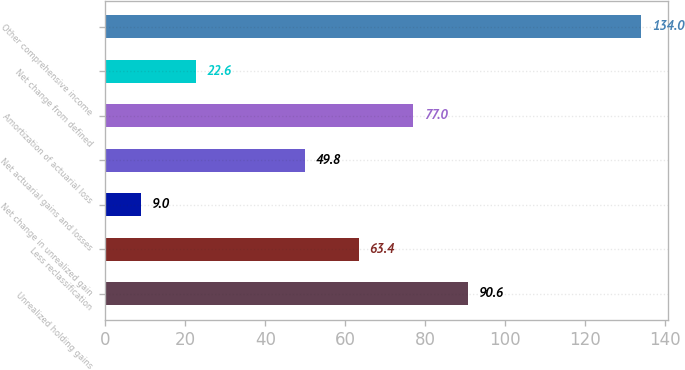Convert chart to OTSL. <chart><loc_0><loc_0><loc_500><loc_500><bar_chart><fcel>Unrealized holding gains<fcel>Less reclassification<fcel>Net change in unrealized gain<fcel>Net actuarial gains and losses<fcel>Amortization of actuarial loss<fcel>Net change from defined<fcel>Other comprehensive income<nl><fcel>90.6<fcel>63.4<fcel>9<fcel>49.8<fcel>77<fcel>22.6<fcel>134<nl></chart> 